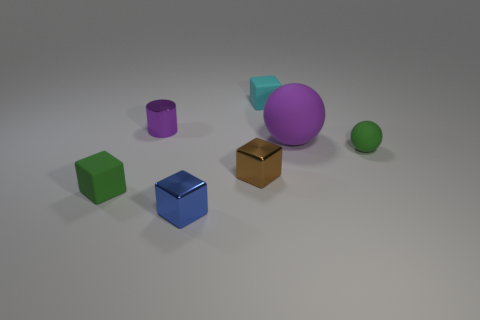Subtract all small green rubber blocks. How many blocks are left? 3 Add 3 small green objects. How many objects exist? 10 Subtract all blue blocks. How many blocks are left? 3 Subtract 1 blocks. How many blocks are left? 3 Subtract all cylinders. How many objects are left? 6 Subtract 1 cyan cubes. How many objects are left? 6 Subtract all green cylinders. Subtract all yellow spheres. How many cylinders are left? 1 Subtract all large matte objects. Subtract all metallic cylinders. How many objects are left? 5 Add 2 small blue blocks. How many small blue blocks are left? 3 Add 1 large blue spheres. How many large blue spheres exist? 1 